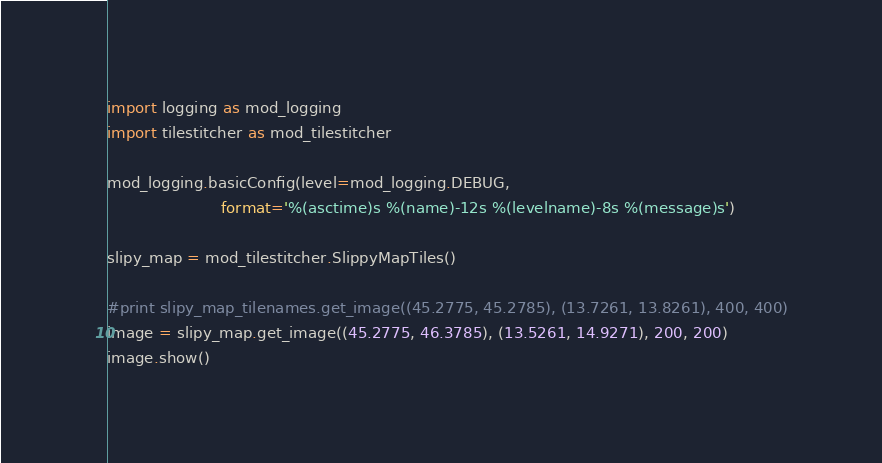Convert code to text. <code><loc_0><loc_0><loc_500><loc_500><_Python_>import logging as mod_logging
import tilestitcher as mod_tilestitcher

mod_logging.basicConfig(level=mod_logging.DEBUG,
                        format='%(asctime)s %(name)-12s %(levelname)-8s %(message)s')

slipy_map = mod_tilestitcher.SlippyMapTiles()

#print slipy_map_tilenames.get_image((45.2775, 45.2785), (13.7261, 13.8261), 400, 400)
image = slipy_map.get_image((45.2775, 46.3785), (13.5261, 14.9271), 200, 200)
image.show()
</code> 